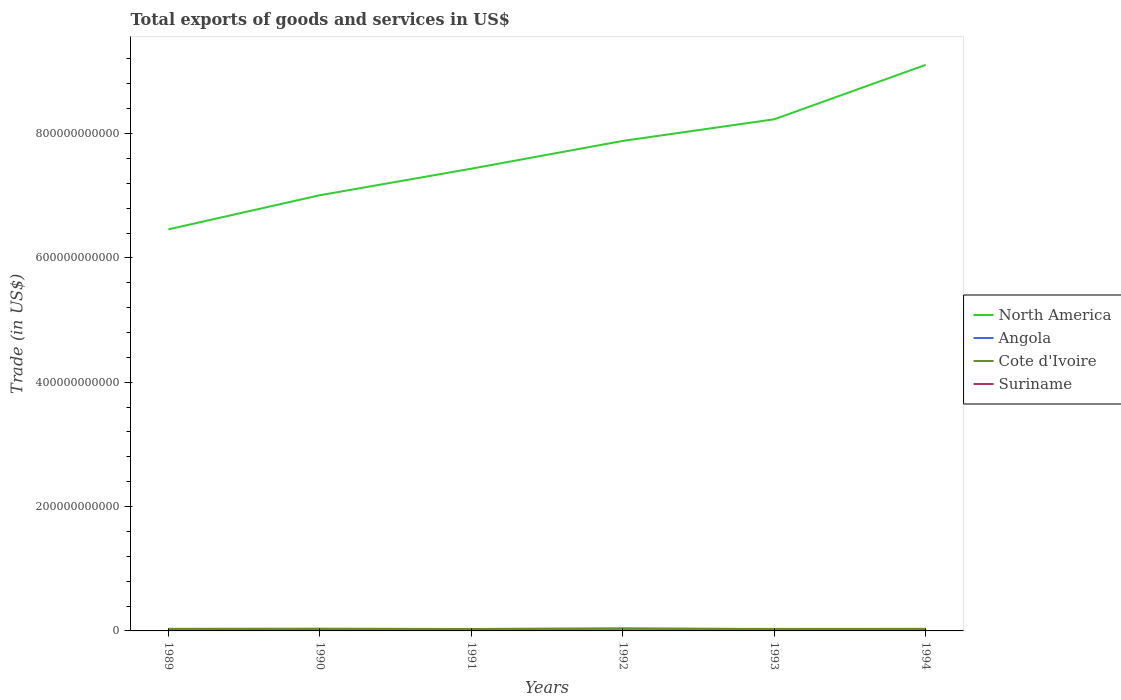Does the line corresponding to North America intersect with the line corresponding to Angola?
Give a very brief answer. No. Across all years, what is the maximum total exports of goods and services in Suriname?
Make the answer very short. 8.75e+07. In which year was the total exports of goods and services in Suriname maximum?
Your response must be concise. 1993. What is the total total exports of goods and services in Suriname in the graph?
Ensure brevity in your answer.  1.80e+07. What is the difference between the highest and the second highest total exports of goods and services in Cote d'Ivoire?
Keep it short and to the point. 4.33e+08. How many lines are there?
Provide a succinct answer. 4. How many years are there in the graph?
Make the answer very short. 6. What is the difference between two consecutive major ticks on the Y-axis?
Provide a short and direct response. 2.00e+11. Does the graph contain any zero values?
Offer a very short reply. No. Does the graph contain grids?
Your response must be concise. No. Where does the legend appear in the graph?
Provide a succinct answer. Center right. What is the title of the graph?
Provide a short and direct response. Total exports of goods and services in US$. What is the label or title of the X-axis?
Your answer should be compact. Years. What is the label or title of the Y-axis?
Your response must be concise. Trade (in US$). What is the Trade (in US$) in North America in 1989?
Provide a succinct answer. 6.46e+11. What is the Trade (in US$) of Angola in 1989?
Ensure brevity in your answer.  3.34e+09. What is the Trade (in US$) in Cote d'Ivoire in 1989?
Your response must be concise. 3.13e+09. What is the Trade (in US$) of Suriname in 1989?
Make the answer very short. 2.05e+08. What is the Trade (in US$) in North America in 1990?
Keep it short and to the point. 7.01e+11. What is the Trade (in US$) of Angola in 1990?
Give a very brief answer. 3.34e+09. What is the Trade (in US$) in Cote d'Ivoire in 1990?
Your response must be concise. 3.42e+09. What is the Trade (in US$) of Suriname in 1990?
Give a very brief answer. 1.63e+08. What is the Trade (in US$) in North America in 1991?
Provide a succinct answer. 7.43e+11. What is the Trade (in US$) in Angola in 1991?
Your answer should be very brief. 3.03e+09. What is the Trade (in US$) of Cote d'Ivoire in 1991?
Offer a terse response. 3.15e+09. What is the Trade (in US$) of Suriname in 1991?
Your answer should be compact. 1.57e+08. What is the Trade (in US$) of North America in 1992?
Your answer should be very brief. 7.88e+11. What is the Trade (in US$) in Angola in 1992?
Give a very brief answer. 3.94e+09. What is the Trade (in US$) in Cote d'Ivoire in 1992?
Provide a succinct answer. 3.56e+09. What is the Trade (in US$) in Suriname in 1992?
Give a very brief answer. 1.16e+08. What is the Trade (in US$) of North America in 1993?
Your answer should be very brief. 8.23e+11. What is the Trade (in US$) in Angola in 1993?
Ensure brevity in your answer.  2.85e+09. What is the Trade (in US$) of Cote d'Ivoire in 1993?
Your answer should be very brief. 3.25e+09. What is the Trade (in US$) in Suriname in 1993?
Make the answer very short. 8.75e+07. What is the Trade (in US$) of North America in 1994?
Your response must be concise. 9.10e+11. What is the Trade (in US$) of Angola in 1994?
Ensure brevity in your answer.  2.65e+09. What is the Trade (in US$) of Cote d'Ivoire in 1994?
Ensure brevity in your answer.  3.37e+09. What is the Trade (in US$) in Suriname in 1994?
Keep it short and to the point. 1.39e+08. Across all years, what is the maximum Trade (in US$) of North America?
Provide a succinct answer. 9.10e+11. Across all years, what is the maximum Trade (in US$) of Angola?
Offer a terse response. 3.94e+09. Across all years, what is the maximum Trade (in US$) of Cote d'Ivoire?
Provide a succinct answer. 3.56e+09. Across all years, what is the maximum Trade (in US$) of Suriname?
Give a very brief answer. 2.05e+08. Across all years, what is the minimum Trade (in US$) of North America?
Ensure brevity in your answer.  6.46e+11. Across all years, what is the minimum Trade (in US$) in Angola?
Offer a terse response. 2.65e+09. Across all years, what is the minimum Trade (in US$) of Cote d'Ivoire?
Ensure brevity in your answer.  3.13e+09. Across all years, what is the minimum Trade (in US$) in Suriname?
Offer a terse response. 8.75e+07. What is the total Trade (in US$) in North America in the graph?
Your answer should be compact. 4.61e+12. What is the total Trade (in US$) of Angola in the graph?
Offer a very short reply. 1.91e+1. What is the total Trade (in US$) of Cote d'Ivoire in the graph?
Give a very brief answer. 1.99e+1. What is the total Trade (in US$) of Suriname in the graph?
Keep it short and to the point. 8.67e+08. What is the difference between the Trade (in US$) in North America in 1989 and that in 1990?
Keep it short and to the point. -5.49e+1. What is the difference between the Trade (in US$) in Cote d'Ivoire in 1989 and that in 1990?
Your response must be concise. -2.96e+08. What is the difference between the Trade (in US$) in Suriname in 1989 and that in 1990?
Ensure brevity in your answer.  4.12e+07. What is the difference between the Trade (in US$) of North America in 1989 and that in 1991?
Ensure brevity in your answer.  -9.76e+1. What is the difference between the Trade (in US$) of Angola in 1989 and that in 1991?
Provide a succinct answer. 3.13e+08. What is the difference between the Trade (in US$) of Cote d'Ivoire in 1989 and that in 1991?
Your response must be concise. -2.34e+07. What is the difference between the Trade (in US$) of Suriname in 1989 and that in 1991?
Give a very brief answer. 4.76e+07. What is the difference between the Trade (in US$) in North America in 1989 and that in 1992?
Give a very brief answer. -1.42e+11. What is the difference between the Trade (in US$) of Angola in 1989 and that in 1992?
Make the answer very short. -5.93e+08. What is the difference between the Trade (in US$) in Cote d'Ivoire in 1989 and that in 1992?
Your answer should be very brief. -4.33e+08. What is the difference between the Trade (in US$) in Suriname in 1989 and that in 1992?
Offer a very short reply. 8.85e+07. What is the difference between the Trade (in US$) of North America in 1989 and that in 1993?
Make the answer very short. -1.77e+11. What is the difference between the Trade (in US$) of Angola in 1989 and that in 1993?
Your answer should be compact. 4.97e+08. What is the difference between the Trade (in US$) of Cote d'Ivoire in 1989 and that in 1993?
Provide a succinct answer. -1.27e+08. What is the difference between the Trade (in US$) in Suriname in 1989 and that in 1993?
Provide a short and direct response. 1.17e+08. What is the difference between the Trade (in US$) of North America in 1989 and that in 1994?
Offer a very short reply. -2.65e+11. What is the difference between the Trade (in US$) in Angola in 1989 and that in 1994?
Provide a succinct answer. 6.95e+08. What is the difference between the Trade (in US$) in Cote d'Ivoire in 1989 and that in 1994?
Give a very brief answer. -2.44e+08. What is the difference between the Trade (in US$) of Suriname in 1989 and that in 1994?
Offer a very short reply. 6.56e+07. What is the difference between the Trade (in US$) in North America in 1990 and that in 1991?
Ensure brevity in your answer.  -4.27e+1. What is the difference between the Trade (in US$) in Angola in 1990 and that in 1991?
Offer a terse response. 3.13e+08. What is the difference between the Trade (in US$) of Cote d'Ivoire in 1990 and that in 1991?
Make the answer very short. 2.72e+08. What is the difference between the Trade (in US$) of Suriname in 1990 and that in 1991?
Your answer should be compact. 6.36e+06. What is the difference between the Trade (in US$) in North America in 1990 and that in 1992?
Offer a very short reply. -8.74e+1. What is the difference between the Trade (in US$) of Angola in 1990 and that in 1992?
Ensure brevity in your answer.  -5.93e+08. What is the difference between the Trade (in US$) in Cote d'Ivoire in 1990 and that in 1992?
Give a very brief answer. -1.38e+08. What is the difference between the Trade (in US$) in Suriname in 1990 and that in 1992?
Ensure brevity in your answer.  4.73e+07. What is the difference between the Trade (in US$) of North America in 1990 and that in 1993?
Provide a succinct answer. -1.22e+11. What is the difference between the Trade (in US$) of Angola in 1990 and that in 1993?
Your answer should be compact. 4.97e+08. What is the difference between the Trade (in US$) of Cote d'Ivoire in 1990 and that in 1993?
Offer a terse response. 1.69e+08. What is the difference between the Trade (in US$) of Suriname in 1990 and that in 1993?
Your answer should be very brief. 7.57e+07. What is the difference between the Trade (in US$) in North America in 1990 and that in 1994?
Make the answer very short. -2.10e+11. What is the difference between the Trade (in US$) in Angola in 1990 and that in 1994?
Your answer should be very brief. 6.95e+08. What is the difference between the Trade (in US$) in Cote d'Ivoire in 1990 and that in 1994?
Make the answer very short. 5.19e+07. What is the difference between the Trade (in US$) in Suriname in 1990 and that in 1994?
Your answer should be compact. 2.44e+07. What is the difference between the Trade (in US$) in North America in 1991 and that in 1992?
Ensure brevity in your answer.  -4.47e+1. What is the difference between the Trade (in US$) in Angola in 1991 and that in 1992?
Give a very brief answer. -9.06e+08. What is the difference between the Trade (in US$) of Cote d'Ivoire in 1991 and that in 1992?
Ensure brevity in your answer.  -4.10e+08. What is the difference between the Trade (in US$) of Suriname in 1991 and that in 1992?
Your answer should be compact. 4.09e+07. What is the difference between the Trade (in US$) in North America in 1991 and that in 1993?
Make the answer very short. -7.95e+1. What is the difference between the Trade (in US$) in Angola in 1991 and that in 1993?
Your answer should be compact. 1.85e+08. What is the difference between the Trade (in US$) of Cote d'Ivoire in 1991 and that in 1993?
Ensure brevity in your answer.  -1.03e+08. What is the difference between the Trade (in US$) in Suriname in 1991 and that in 1993?
Provide a succinct answer. 6.94e+07. What is the difference between the Trade (in US$) of North America in 1991 and that in 1994?
Make the answer very short. -1.67e+11. What is the difference between the Trade (in US$) in Angola in 1991 and that in 1994?
Your response must be concise. 3.83e+08. What is the difference between the Trade (in US$) of Cote d'Ivoire in 1991 and that in 1994?
Your answer should be very brief. -2.20e+08. What is the difference between the Trade (in US$) of Suriname in 1991 and that in 1994?
Your answer should be very brief. 1.80e+07. What is the difference between the Trade (in US$) in North America in 1992 and that in 1993?
Your answer should be compact. -3.48e+1. What is the difference between the Trade (in US$) of Angola in 1992 and that in 1993?
Your response must be concise. 1.09e+09. What is the difference between the Trade (in US$) in Cote d'Ivoire in 1992 and that in 1993?
Provide a succinct answer. 3.07e+08. What is the difference between the Trade (in US$) of Suriname in 1992 and that in 1993?
Your answer should be compact. 2.84e+07. What is the difference between the Trade (in US$) of North America in 1992 and that in 1994?
Give a very brief answer. -1.22e+11. What is the difference between the Trade (in US$) in Angola in 1992 and that in 1994?
Your answer should be very brief. 1.29e+09. What is the difference between the Trade (in US$) of Cote d'Ivoire in 1992 and that in 1994?
Make the answer very short. 1.90e+08. What is the difference between the Trade (in US$) of Suriname in 1992 and that in 1994?
Your answer should be compact. -2.29e+07. What is the difference between the Trade (in US$) of North America in 1993 and that in 1994?
Offer a terse response. -8.75e+1. What is the difference between the Trade (in US$) of Angola in 1993 and that in 1994?
Make the answer very short. 1.98e+08. What is the difference between the Trade (in US$) in Cote d'Ivoire in 1993 and that in 1994?
Provide a succinct answer. -1.17e+08. What is the difference between the Trade (in US$) in Suriname in 1993 and that in 1994?
Your answer should be very brief. -5.14e+07. What is the difference between the Trade (in US$) of North America in 1989 and the Trade (in US$) of Angola in 1990?
Your answer should be compact. 6.43e+11. What is the difference between the Trade (in US$) in North America in 1989 and the Trade (in US$) in Cote d'Ivoire in 1990?
Your response must be concise. 6.42e+11. What is the difference between the Trade (in US$) in North America in 1989 and the Trade (in US$) in Suriname in 1990?
Offer a terse response. 6.46e+11. What is the difference between the Trade (in US$) of Angola in 1989 and the Trade (in US$) of Cote d'Ivoire in 1990?
Provide a succinct answer. -7.89e+07. What is the difference between the Trade (in US$) of Angola in 1989 and the Trade (in US$) of Suriname in 1990?
Your answer should be very brief. 3.18e+09. What is the difference between the Trade (in US$) of Cote d'Ivoire in 1989 and the Trade (in US$) of Suriname in 1990?
Your answer should be very brief. 2.96e+09. What is the difference between the Trade (in US$) in North America in 1989 and the Trade (in US$) in Angola in 1991?
Your response must be concise. 6.43e+11. What is the difference between the Trade (in US$) of North America in 1989 and the Trade (in US$) of Cote d'Ivoire in 1991?
Keep it short and to the point. 6.43e+11. What is the difference between the Trade (in US$) of North America in 1989 and the Trade (in US$) of Suriname in 1991?
Offer a terse response. 6.46e+11. What is the difference between the Trade (in US$) of Angola in 1989 and the Trade (in US$) of Cote d'Ivoire in 1991?
Your response must be concise. 1.93e+08. What is the difference between the Trade (in US$) of Angola in 1989 and the Trade (in US$) of Suriname in 1991?
Ensure brevity in your answer.  3.19e+09. What is the difference between the Trade (in US$) in Cote d'Ivoire in 1989 and the Trade (in US$) in Suriname in 1991?
Provide a short and direct response. 2.97e+09. What is the difference between the Trade (in US$) of North America in 1989 and the Trade (in US$) of Angola in 1992?
Your answer should be very brief. 6.42e+11. What is the difference between the Trade (in US$) of North America in 1989 and the Trade (in US$) of Cote d'Ivoire in 1992?
Offer a very short reply. 6.42e+11. What is the difference between the Trade (in US$) of North America in 1989 and the Trade (in US$) of Suriname in 1992?
Provide a short and direct response. 6.46e+11. What is the difference between the Trade (in US$) in Angola in 1989 and the Trade (in US$) in Cote d'Ivoire in 1992?
Give a very brief answer. -2.17e+08. What is the difference between the Trade (in US$) of Angola in 1989 and the Trade (in US$) of Suriname in 1992?
Your answer should be compact. 3.23e+09. What is the difference between the Trade (in US$) in Cote d'Ivoire in 1989 and the Trade (in US$) in Suriname in 1992?
Your answer should be compact. 3.01e+09. What is the difference between the Trade (in US$) in North America in 1989 and the Trade (in US$) in Angola in 1993?
Provide a short and direct response. 6.43e+11. What is the difference between the Trade (in US$) of North America in 1989 and the Trade (in US$) of Cote d'Ivoire in 1993?
Offer a very short reply. 6.43e+11. What is the difference between the Trade (in US$) in North America in 1989 and the Trade (in US$) in Suriname in 1993?
Your answer should be very brief. 6.46e+11. What is the difference between the Trade (in US$) of Angola in 1989 and the Trade (in US$) of Cote d'Ivoire in 1993?
Your answer should be compact. 9.01e+07. What is the difference between the Trade (in US$) in Angola in 1989 and the Trade (in US$) in Suriname in 1993?
Offer a terse response. 3.25e+09. What is the difference between the Trade (in US$) of Cote d'Ivoire in 1989 and the Trade (in US$) of Suriname in 1993?
Keep it short and to the point. 3.04e+09. What is the difference between the Trade (in US$) in North America in 1989 and the Trade (in US$) in Angola in 1994?
Offer a terse response. 6.43e+11. What is the difference between the Trade (in US$) of North America in 1989 and the Trade (in US$) of Cote d'Ivoire in 1994?
Your answer should be very brief. 6.43e+11. What is the difference between the Trade (in US$) in North America in 1989 and the Trade (in US$) in Suriname in 1994?
Offer a terse response. 6.46e+11. What is the difference between the Trade (in US$) of Angola in 1989 and the Trade (in US$) of Cote d'Ivoire in 1994?
Your answer should be very brief. -2.70e+07. What is the difference between the Trade (in US$) of Angola in 1989 and the Trade (in US$) of Suriname in 1994?
Offer a terse response. 3.20e+09. What is the difference between the Trade (in US$) in Cote d'Ivoire in 1989 and the Trade (in US$) in Suriname in 1994?
Offer a very short reply. 2.99e+09. What is the difference between the Trade (in US$) in North America in 1990 and the Trade (in US$) in Angola in 1991?
Make the answer very short. 6.98e+11. What is the difference between the Trade (in US$) of North America in 1990 and the Trade (in US$) of Cote d'Ivoire in 1991?
Your answer should be very brief. 6.98e+11. What is the difference between the Trade (in US$) of North America in 1990 and the Trade (in US$) of Suriname in 1991?
Ensure brevity in your answer.  7.01e+11. What is the difference between the Trade (in US$) in Angola in 1990 and the Trade (in US$) in Cote d'Ivoire in 1991?
Provide a short and direct response. 1.93e+08. What is the difference between the Trade (in US$) of Angola in 1990 and the Trade (in US$) of Suriname in 1991?
Your answer should be very brief. 3.19e+09. What is the difference between the Trade (in US$) in Cote d'Ivoire in 1990 and the Trade (in US$) in Suriname in 1991?
Offer a very short reply. 3.26e+09. What is the difference between the Trade (in US$) of North America in 1990 and the Trade (in US$) of Angola in 1992?
Offer a terse response. 6.97e+11. What is the difference between the Trade (in US$) of North America in 1990 and the Trade (in US$) of Cote d'Ivoire in 1992?
Make the answer very short. 6.97e+11. What is the difference between the Trade (in US$) of North America in 1990 and the Trade (in US$) of Suriname in 1992?
Your answer should be compact. 7.01e+11. What is the difference between the Trade (in US$) in Angola in 1990 and the Trade (in US$) in Cote d'Ivoire in 1992?
Offer a terse response. -2.17e+08. What is the difference between the Trade (in US$) of Angola in 1990 and the Trade (in US$) of Suriname in 1992?
Make the answer very short. 3.23e+09. What is the difference between the Trade (in US$) in Cote d'Ivoire in 1990 and the Trade (in US$) in Suriname in 1992?
Make the answer very short. 3.31e+09. What is the difference between the Trade (in US$) in North America in 1990 and the Trade (in US$) in Angola in 1993?
Provide a succinct answer. 6.98e+11. What is the difference between the Trade (in US$) of North America in 1990 and the Trade (in US$) of Cote d'Ivoire in 1993?
Provide a short and direct response. 6.98e+11. What is the difference between the Trade (in US$) in North America in 1990 and the Trade (in US$) in Suriname in 1993?
Ensure brevity in your answer.  7.01e+11. What is the difference between the Trade (in US$) in Angola in 1990 and the Trade (in US$) in Cote d'Ivoire in 1993?
Provide a succinct answer. 9.01e+07. What is the difference between the Trade (in US$) of Angola in 1990 and the Trade (in US$) of Suriname in 1993?
Your response must be concise. 3.25e+09. What is the difference between the Trade (in US$) in Cote d'Ivoire in 1990 and the Trade (in US$) in Suriname in 1993?
Your answer should be compact. 3.33e+09. What is the difference between the Trade (in US$) of North America in 1990 and the Trade (in US$) of Angola in 1994?
Offer a very short reply. 6.98e+11. What is the difference between the Trade (in US$) in North America in 1990 and the Trade (in US$) in Cote d'Ivoire in 1994?
Your response must be concise. 6.97e+11. What is the difference between the Trade (in US$) of North America in 1990 and the Trade (in US$) of Suriname in 1994?
Your response must be concise. 7.01e+11. What is the difference between the Trade (in US$) of Angola in 1990 and the Trade (in US$) of Cote d'Ivoire in 1994?
Provide a short and direct response. -2.70e+07. What is the difference between the Trade (in US$) in Angola in 1990 and the Trade (in US$) in Suriname in 1994?
Your answer should be compact. 3.20e+09. What is the difference between the Trade (in US$) in Cote d'Ivoire in 1990 and the Trade (in US$) in Suriname in 1994?
Give a very brief answer. 3.28e+09. What is the difference between the Trade (in US$) of North America in 1991 and the Trade (in US$) of Angola in 1992?
Keep it short and to the point. 7.40e+11. What is the difference between the Trade (in US$) of North America in 1991 and the Trade (in US$) of Cote d'Ivoire in 1992?
Your response must be concise. 7.40e+11. What is the difference between the Trade (in US$) of North America in 1991 and the Trade (in US$) of Suriname in 1992?
Provide a short and direct response. 7.43e+11. What is the difference between the Trade (in US$) in Angola in 1991 and the Trade (in US$) in Cote d'Ivoire in 1992?
Offer a terse response. -5.29e+08. What is the difference between the Trade (in US$) of Angola in 1991 and the Trade (in US$) of Suriname in 1992?
Your answer should be compact. 2.91e+09. What is the difference between the Trade (in US$) of Cote d'Ivoire in 1991 and the Trade (in US$) of Suriname in 1992?
Offer a very short reply. 3.03e+09. What is the difference between the Trade (in US$) of North America in 1991 and the Trade (in US$) of Angola in 1993?
Provide a succinct answer. 7.41e+11. What is the difference between the Trade (in US$) in North America in 1991 and the Trade (in US$) in Cote d'Ivoire in 1993?
Provide a short and direct response. 7.40e+11. What is the difference between the Trade (in US$) of North America in 1991 and the Trade (in US$) of Suriname in 1993?
Offer a terse response. 7.43e+11. What is the difference between the Trade (in US$) of Angola in 1991 and the Trade (in US$) of Cote d'Ivoire in 1993?
Offer a terse response. -2.22e+08. What is the difference between the Trade (in US$) of Angola in 1991 and the Trade (in US$) of Suriname in 1993?
Offer a terse response. 2.94e+09. What is the difference between the Trade (in US$) in Cote d'Ivoire in 1991 and the Trade (in US$) in Suriname in 1993?
Make the answer very short. 3.06e+09. What is the difference between the Trade (in US$) in North America in 1991 and the Trade (in US$) in Angola in 1994?
Ensure brevity in your answer.  7.41e+11. What is the difference between the Trade (in US$) of North America in 1991 and the Trade (in US$) of Cote d'Ivoire in 1994?
Provide a succinct answer. 7.40e+11. What is the difference between the Trade (in US$) in North America in 1991 and the Trade (in US$) in Suriname in 1994?
Make the answer very short. 7.43e+11. What is the difference between the Trade (in US$) of Angola in 1991 and the Trade (in US$) of Cote d'Ivoire in 1994?
Your response must be concise. -3.40e+08. What is the difference between the Trade (in US$) of Angola in 1991 and the Trade (in US$) of Suriname in 1994?
Your answer should be compact. 2.89e+09. What is the difference between the Trade (in US$) in Cote d'Ivoire in 1991 and the Trade (in US$) in Suriname in 1994?
Offer a terse response. 3.01e+09. What is the difference between the Trade (in US$) of North America in 1992 and the Trade (in US$) of Angola in 1993?
Ensure brevity in your answer.  7.85e+11. What is the difference between the Trade (in US$) of North America in 1992 and the Trade (in US$) of Cote d'Ivoire in 1993?
Offer a very short reply. 7.85e+11. What is the difference between the Trade (in US$) of North America in 1992 and the Trade (in US$) of Suriname in 1993?
Keep it short and to the point. 7.88e+11. What is the difference between the Trade (in US$) of Angola in 1992 and the Trade (in US$) of Cote d'Ivoire in 1993?
Your response must be concise. 6.83e+08. What is the difference between the Trade (in US$) of Angola in 1992 and the Trade (in US$) of Suriname in 1993?
Your answer should be compact. 3.85e+09. What is the difference between the Trade (in US$) in Cote d'Ivoire in 1992 and the Trade (in US$) in Suriname in 1993?
Your response must be concise. 3.47e+09. What is the difference between the Trade (in US$) of North America in 1992 and the Trade (in US$) of Angola in 1994?
Your answer should be very brief. 7.86e+11. What is the difference between the Trade (in US$) in North America in 1992 and the Trade (in US$) in Cote d'Ivoire in 1994?
Offer a very short reply. 7.85e+11. What is the difference between the Trade (in US$) in North America in 1992 and the Trade (in US$) in Suriname in 1994?
Ensure brevity in your answer.  7.88e+11. What is the difference between the Trade (in US$) of Angola in 1992 and the Trade (in US$) of Cote d'Ivoire in 1994?
Your answer should be compact. 5.66e+08. What is the difference between the Trade (in US$) of Angola in 1992 and the Trade (in US$) of Suriname in 1994?
Offer a very short reply. 3.80e+09. What is the difference between the Trade (in US$) of Cote d'Ivoire in 1992 and the Trade (in US$) of Suriname in 1994?
Provide a succinct answer. 3.42e+09. What is the difference between the Trade (in US$) of North America in 1993 and the Trade (in US$) of Angola in 1994?
Give a very brief answer. 8.20e+11. What is the difference between the Trade (in US$) of North America in 1993 and the Trade (in US$) of Cote d'Ivoire in 1994?
Your answer should be very brief. 8.20e+11. What is the difference between the Trade (in US$) of North America in 1993 and the Trade (in US$) of Suriname in 1994?
Offer a terse response. 8.23e+11. What is the difference between the Trade (in US$) of Angola in 1993 and the Trade (in US$) of Cote d'Ivoire in 1994?
Provide a short and direct response. -5.24e+08. What is the difference between the Trade (in US$) of Angola in 1993 and the Trade (in US$) of Suriname in 1994?
Ensure brevity in your answer.  2.71e+09. What is the difference between the Trade (in US$) in Cote d'Ivoire in 1993 and the Trade (in US$) in Suriname in 1994?
Ensure brevity in your answer.  3.11e+09. What is the average Trade (in US$) in North America per year?
Give a very brief answer. 7.69e+11. What is the average Trade (in US$) in Angola per year?
Provide a succinct answer. 3.19e+09. What is the average Trade (in US$) in Cote d'Ivoire per year?
Give a very brief answer. 3.31e+09. What is the average Trade (in US$) of Suriname per year?
Provide a short and direct response. 1.45e+08. In the year 1989, what is the difference between the Trade (in US$) in North America and Trade (in US$) in Angola?
Ensure brevity in your answer.  6.43e+11. In the year 1989, what is the difference between the Trade (in US$) in North America and Trade (in US$) in Cote d'Ivoire?
Make the answer very short. 6.43e+11. In the year 1989, what is the difference between the Trade (in US$) in North America and Trade (in US$) in Suriname?
Ensure brevity in your answer.  6.46e+11. In the year 1989, what is the difference between the Trade (in US$) of Angola and Trade (in US$) of Cote d'Ivoire?
Keep it short and to the point. 2.17e+08. In the year 1989, what is the difference between the Trade (in US$) in Angola and Trade (in US$) in Suriname?
Make the answer very short. 3.14e+09. In the year 1989, what is the difference between the Trade (in US$) in Cote d'Ivoire and Trade (in US$) in Suriname?
Provide a succinct answer. 2.92e+09. In the year 1990, what is the difference between the Trade (in US$) in North America and Trade (in US$) in Angola?
Keep it short and to the point. 6.97e+11. In the year 1990, what is the difference between the Trade (in US$) of North America and Trade (in US$) of Cote d'Ivoire?
Make the answer very short. 6.97e+11. In the year 1990, what is the difference between the Trade (in US$) in North America and Trade (in US$) in Suriname?
Provide a short and direct response. 7.01e+11. In the year 1990, what is the difference between the Trade (in US$) of Angola and Trade (in US$) of Cote d'Ivoire?
Make the answer very short. -7.89e+07. In the year 1990, what is the difference between the Trade (in US$) of Angola and Trade (in US$) of Suriname?
Ensure brevity in your answer.  3.18e+09. In the year 1990, what is the difference between the Trade (in US$) in Cote d'Ivoire and Trade (in US$) in Suriname?
Your answer should be compact. 3.26e+09. In the year 1991, what is the difference between the Trade (in US$) of North America and Trade (in US$) of Angola?
Offer a very short reply. 7.40e+11. In the year 1991, what is the difference between the Trade (in US$) of North America and Trade (in US$) of Cote d'Ivoire?
Offer a terse response. 7.40e+11. In the year 1991, what is the difference between the Trade (in US$) in North America and Trade (in US$) in Suriname?
Make the answer very short. 7.43e+11. In the year 1991, what is the difference between the Trade (in US$) of Angola and Trade (in US$) of Cote d'Ivoire?
Offer a very short reply. -1.19e+08. In the year 1991, what is the difference between the Trade (in US$) in Angola and Trade (in US$) in Suriname?
Your answer should be compact. 2.87e+09. In the year 1991, what is the difference between the Trade (in US$) in Cote d'Ivoire and Trade (in US$) in Suriname?
Your response must be concise. 2.99e+09. In the year 1992, what is the difference between the Trade (in US$) in North America and Trade (in US$) in Angola?
Keep it short and to the point. 7.84e+11. In the year 1992, what is the difference between the Trade (in US$) of North America and Trade (in US$) of Cote d'Ivoire?
Offer a very short reply. 7.85e+11. In the year 1992, what is the difference between the Trade (in US$) in North America and Trade (in US$) in Suriname?
Offer a terse response. 7.88e+11. In the year 1992, what is the difference between the Trade (in US$) in Angola and Trade (in US$) in Cote d'Ivoire?
Provide a succinct answer. 3.76e+08. In the year 1992, what is the difference between the Trade (in US$) in Angola and Trade (in US$) in Suriname?
Your response must be concise. 3.82e+09. In the year 1992, what is the difference between the Trade (in US$) in Cote d'Ivoire and Trade (in US$) in Suriname?
Give a very brief answer. 3.44e+09. In the year 1993, what is the difference between the Trade (in US$) of North America and Trade (in US$) of Angola?
Your response must be concise. 8.20e+11. In the year 1993, what is the difference between the Trade (in US$) in North America and Trade (in US$) in Cote d'Ivoire?
Ensure brevity in your answer.  8.20e+11. In the year 1993, what is the difference between the Trade (in US$) of North America and Trade (in US$) of Suriname?
Your answer should be compact. 8.23e+11. In the year 1993, what is the difference between the Trade (in US$) of Angola and Trade (in US$) of Cote d'Ivoire?
Provide a short and direct response. -4.07e+08. In the year 1993, what is the difference between the Trade (in US$) in Angola and Trade (in US$) in Suriname?
Your response must be concise. 2.76e+09. In the year 1993, what is the difference between the Trade (in US$) of Cote d'Ivoire and Trade (in US$) of Suriname?
Keep it short and to the point. 3.16e+09. In the year 1994, what is the difference between the Trade (in US$) in North America and Trade (in US$) in Angola?
Give a very brief answer. 9.08e+11. In the year 1994, what is the difference between the Trade (in US$) of North America and Trade (in US$) of Cote d'Ivoire?
Your response must be concise. 9.07e+11. In the year 1994, what is the difference between the Trade (in US$) of North America and Trade (in US$) of Suriname?
Give a very brief answer. 9.10e+11. In the year 1994, what is the difference between the Trade (in US$) in Angola and Trade (in US$) in Cote d'Ivoire?
Your answer should be very brief. -7.22e+08. In the year 1994, what is the difference between the Trade (in US$) of Angola and Trade (in US$) of Suriname?
Your answer should be very brief. 2.51e+09. In the year 1994, what is the difference between the Trade (in US$) in Cote d'Ivoire and Trade (in US$) in Suriname?
Give a very brief answer. 3.23e+09. What is the ratio of the Trade (in US$) in North America in 1989 to that in 1990?
Your answer should be very brief. 0.92. What is the ratio of the Trade (in US$) of Cote d'Ivoire in 1989 to that in 1990?
Your answer should be very brief. 0.91. What is the ratio of the Trade (in US$) in Suriname in 1989 to that in 1990?
Ensure brevity in your answer.  1.25. What is the ratio of the Trade (in US$) of North America in 1989 to that in 1991?
Provide a succinct answer. 0.87. What is the ratio of the Trade (in US$) in Angola in 1989 to that in 1991?
Offer a terse response. 1.1. What is the ratio of the Trade (in US$) in Suriname in 1989 to that in 1991?
Offer a terse response. 1.3. What is the ratio of the Trade (in US$) of North America in 1989 to that in 1992?
Offer a terse response. 0.82. What is the ratio of the Trade (in US$) of Angola in 1989 to that in 1992?
Offer a terse response. 0.85. What is the ratio of the Trade (in US$) in Cote d'Ivoire in 1989 to that in 1992?
Provide a short and direct response. 0.88. What is the ratio of the Trade (in US$) of Suriname in 1989 to that in 1992?
Ensure brevity in your answer.  1.76. What is the ratio of the Trade (in US$) of North America in 1989 to that in 1993?
Provide a succinct answer. 0.78. What is the ratio of the Trade (in US$) of Angola in 1989 to that in 1993?
Give a very brief answer. 1.17. What is the ratio of the Trade (in US$) of Cote d'Ivoire in 1989 to that in 1993?
Offer a very short reply. 0.96. What is the ratio of the Trade (in US$) in Suriname in 1989 to that in 1993?
Your response must be concise. 2.34. What is the ratio of the Trade (in US$) of North America in 1989 to that in 1994?
Your response must be concise. 0.71. What is the ratio of the Trade (in US$) in Angola in 1989 to that in 1994?
Provide a short and direct response. 1.26. What is the ratio of the Trade (in US$) of Cote d'Ivoire in 1989 to that in 1994?
Ensure brevity in your answer.  0.93. What is the ratio of the Trade (in US$) in Suriname in 1989 to that in 1994?
Provide a succinct answer. 1.47. What is the ratio of the Trade (in US$) in North America in 1990 to that in 1991?
Give a very brief answer. 0.94. What is the ratio of the Trade (in US$) in Angola in 1990 to that in 1991?
Your response must be concise. 1.1. What is the ratio of the Trade (in US$) in Cote d'Ivoire in 1990 to that in 1991?
Offer a terse response. 1.09. What is the ratio of the Trade (in US$) of Suriname in 1990 to that in 1991?
Make the answer very short. 1.04. What is the ratio of the Trade (in US$) of North America in 1990 to that in 1992?
Make the answer very short. 0.89. What is the ratio of the Trade (in US$) in Angola in 1990 to that in 1992?
Offer a terse response. 0.85. What is the ratio of the Trade (in US$) in Cote d'Ivoire in 1990 to that in 1992?
Ensure brevity in your answer.  0.96. What is the ratio of the Trade (in US$) of Suriname in 1990 to that in 1992?
Your answer should be compact. 1.41. What is the ratio of the Trade (in US$) of North America in 1990 to that in 1993?
Your answer should be very brief. 0.85. What is the ratio of the Trade (in US$) of Angola in 1990 to that in 1993?
Give a very brief answer. 1.17. What is the ratio of the Trade (in US$) in Cote d'Ivoire in 1990 to that in 1993?
Provide a short and direct response. 1.05. What is the ratio of the Trade (in US$) in Suriname in 1990 to that in 1993?
Keep it short and to the point. 1.87. What is the ratio of the Trade (in US$) in North America in 1990 to that in 1994?
Give a very brief answer. 0.77. What is the ratio of the Trade (in US$) of Angola in 1990 to that in 1994?
Your answer should be very brief. 1.26. What is the ratio of the Trade (in US$) of Cote d'Ivoire in 1990 to that in 1994?
Your response must be concise. 1.02. What is the ratio of the Trade (in US$) of Suriname in 1990 to that in 1994?
Your response must be concise. 1.18. What is the ratio of the Trade (in US$) in North America in 1991 to that in 1992?
Provide a short and direct response. 0.94. What is the ratio of the Trade (in US$) of Angola in 1991 to that in 1992?
Your answer should be compact. 0.77. What is the ratio of the Trade (in US$) in Cote d'Ivoire in 1991 to that in 1992?
Keep it short and to the point. 0.88. What is the ratio of the Trade (in US$) in Suriname in 1991 to that in 1992?
Offer a very short reply. 1.35. What is the ratio of the Trade (in US$) of North America in 1991 to that in 1993?
Your answer should be very brief. 0.9. What is the ratio of the Trade (in US$) in Angola in 1991 to that in 1993?
Make the answer very short. 1.06. What is the ratio of the Trade (in US$) in Cote d'Ivoire in 1991 to that in 1993?
Give a very brief answer. 0.97. What is the ratio of the Trade (in US$) of Suriname in 1991 to that in 1993?
Provide a succinct answer. 1.79. What is the ratio of the Trade (in US$) in North America in 1991 to that in 1994?
Give a very brief answer. 0.82. What is the ratio of the Trade (in US$) in Angola in 1991 to that in 1994?
Keep it short and to the point. 1.14. What is the ratio of the Trade (in US$) in Cote d'Ivoire in 1991 to that in 1994?
Offer a very short reply. 0.93. What is the ratio of the Trade (in US$) of Suriname in 1991 to that in 1994?
Give a very brief answer. 1.13. What is the ratio of the Trade (in US$) of North America in 1992 to that in 1993?
Your answer should be very brief. 0.96. What is the ratio of the Trade (in US$) in Angola in 1992 to that in 1993?
Ensure brevity in your answer.  1.38. What is the ratio of the Trade (in US$) of Cote d'Ivoire in 1992 to that in 1993?
Offer a terse response. 1.09. What is the ratio of the Trade (in US$) of Suriname in 1992 to that in 1993?
Your answer should be very brief. 1.32. What is the ratio of the Trade (in US$) of North America in 1992 to that in 1994?
Ensure brevity in your answer.  0.87. What is the ratio of the Trade (in US$) in Angola in 1992 to that in 1994?
Provide a short and direct response. 1.49. What is the ratio of the Trade (in US$) in Cote d'Ivoire in 1992 to that in 1994?
Keep it short and to the point. 1.06. What is the ratio of the Trade (in US$) of Suriname in 1992 to that in 1994?
Your answer should be compact. 0.83. What is the ratio of the Trade (in US$) in North America in 1993 to that in 1994?
Make the answer very short. 0.9. What is the ratio of the Trade (in US$) in Angola in 1993 to that in 1994?
Keep it short and to the point. 1.07. What is the ratio of the Trade (in US$) in Cote d'Ivoire in 1993 to that in 1994?
Keep it short and to the point. 0.97. What is the ratio of the Trade (in US$) of Suriname in 1993 to that in 1994?
Ensure brevity in your answer.  0.63. What is the difference between the highest and the second highest Trade (in US$) in North America?
Offer a very short reply. 8.75e+1. What is the difference between the highest and the second highest Trade (in US$) of Angola?
Your answer should be very brief. 5.93e+08. What is the difference between the highest and the second highest Trade (in US$) of Cote d'Ivoire?
Provide a succinct answer. 1.38e+08. What is the difference between the highest and the second highest Trade (in US$) in Suriname?
Offer a very short reply. 4.12e+07. What is the difference between the highest and the lowest Trade (in US$) in North America?
Offer a terse response. 2.65e+11. What is the difference between the highest and the lowest Trade (in US$) in Angola?
Ensure brevity in your answer.  1.29e+09. What is the difference between the highest and the lowest Trade (in US$) in Cote d'Ivoire?
Ensure brevity in your answer.  4.33e+08. What is the difference between the highest and the lowest Trade (in US$) of Suriname?
Your response must be concise. 1.17e+08. 